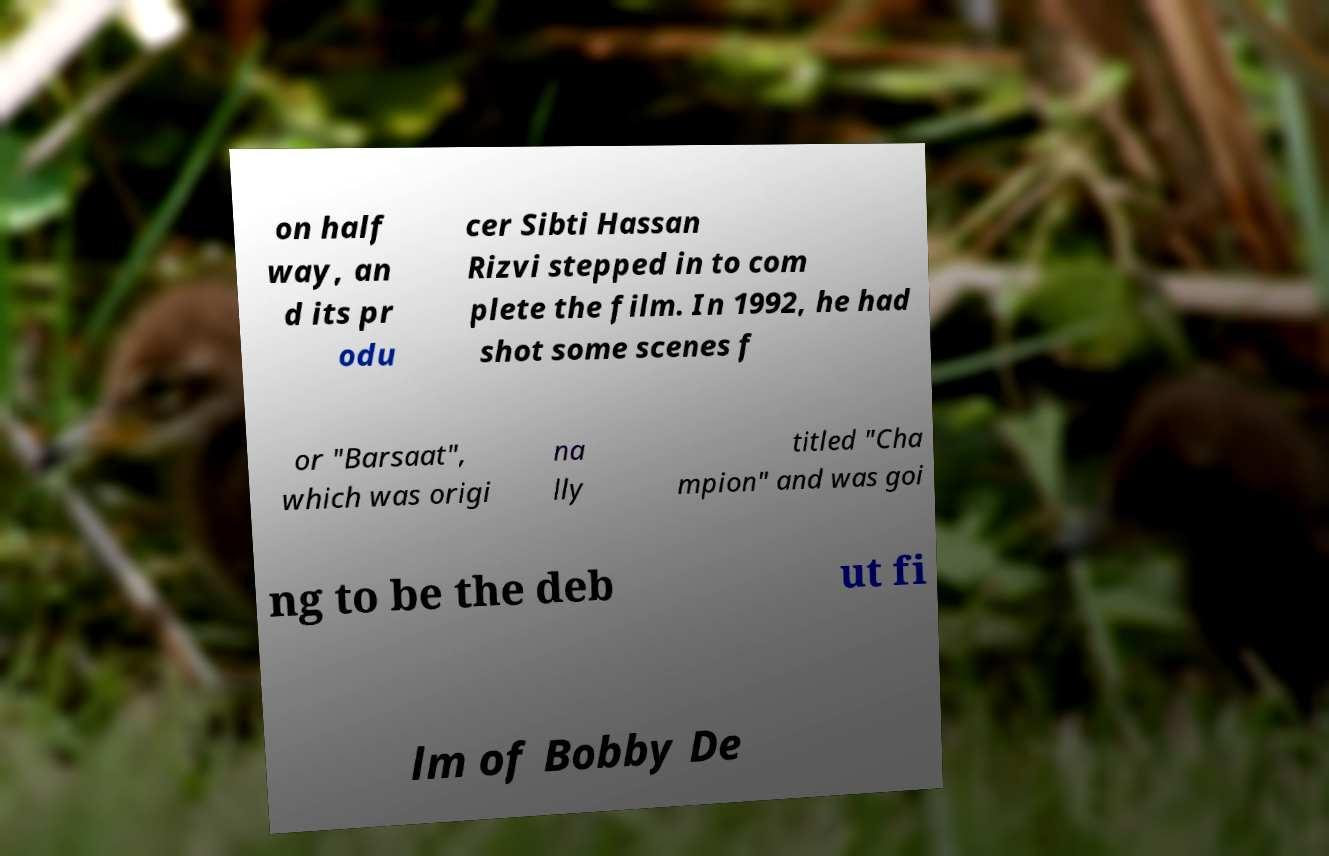Could you extract and type out the text from this image? on half way, an d its pr odu cer Sibti Hassan Rizvi stepped in to com plete the film. In 1992, he had shot some scenes f or "Barsaat", which was origi na lly titled "Cha mpion" and was goi ng to be the deb ut fi lm of Bobby De 